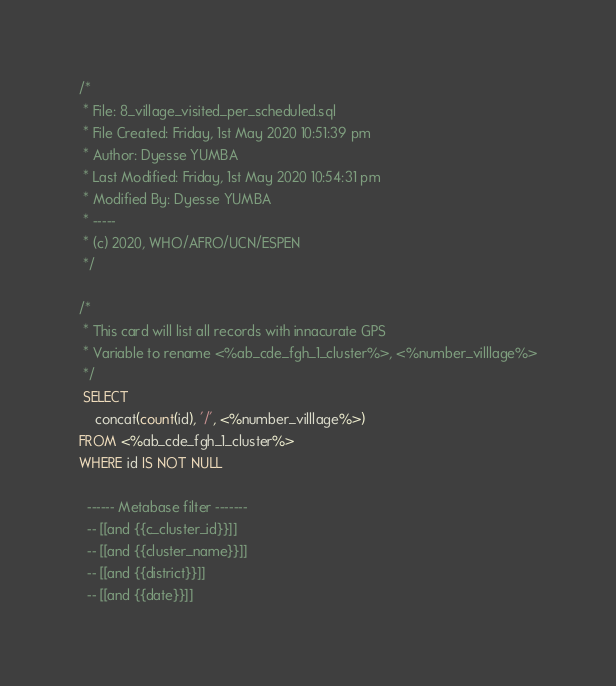<code> <loc_0><loc_0><loc_500><loc_500><_SQL_>/*
 * File: 8_village_visited_per_scheduled.sql
 * File Created: Friday, 1st May 2020 10:51:39 pm
 * Author: Dyesse YUMBA
 * Last Modified: Friday, 1st May 2020 10:54:31 pm
 * Modified By: Dyesse YUMBA
 * -----
 * (c) 2020, WHO/AFRO/UCN/ESPEN
 */

/*
 * This card will list all records with innacurate GPS
 * Variable to rename <%ab_cde_fgh_1_cluster%>, <%number_villlage%>
 */
 SELECT
	concat(count(id), '/', <%number_villlage%>)
FROM <%ab_cde_fgh_1_cluster%>
WHERE id IS NOT NULL

  ------ Metabase filter -------
  -- [[and {{c_cluster_id}}]]
  -- [[and {{cluster_name}}]]
  -- [[and {{district}}]]
  -- [[and {{date}}]]
</code> 